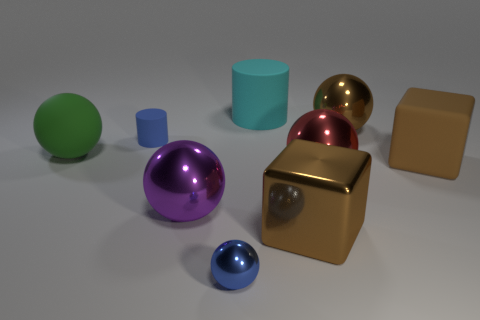Subtract all big red balls. How many balls are left? 4 Subtract all green spheres. How many spheres are left? 4 Subtract 3 balls. How many balls are left? 2 Add 1 large brown spheres. How many objects exist? 10 Subtract all purple balls. Subtract all yellow blocks. How many balls are left? 4 Subtract all tiny cyan rubber spheres. Subtract all red metallic balls. How many objects are left? 8 Add 9 large rubber balls. How many large rubber balls are left? 10 Add 5 big green things. How many big green things exist? 6 Subtract 1 brown balls. How many objects are left? 8 Subtract all cylinders. How many objects are left? 7 